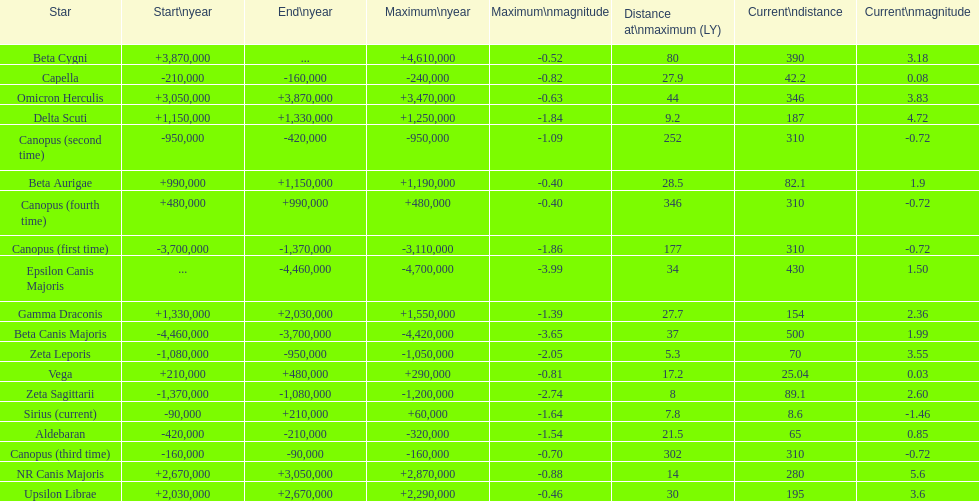What is the only star with a distance at maximum of 80? Beta Cygni. 